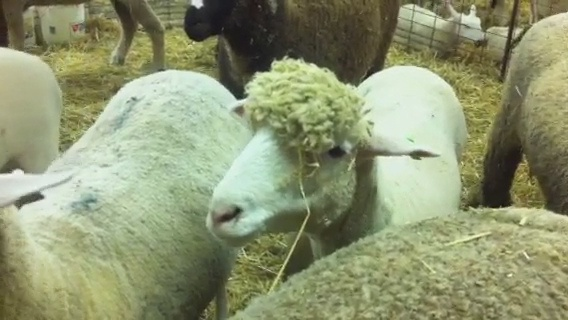Describe the objects in this image and their specific colors. I can see sheep in black, beige, olive, and darkgray tones, sheep in black, beige, olive, and darkgreen tones, sheep in black, olive, tan, and khaki tones, sheep in black, darkgreen, and gray tones, and sheep in black, olive, gray, and darkgreen tones in this image. 